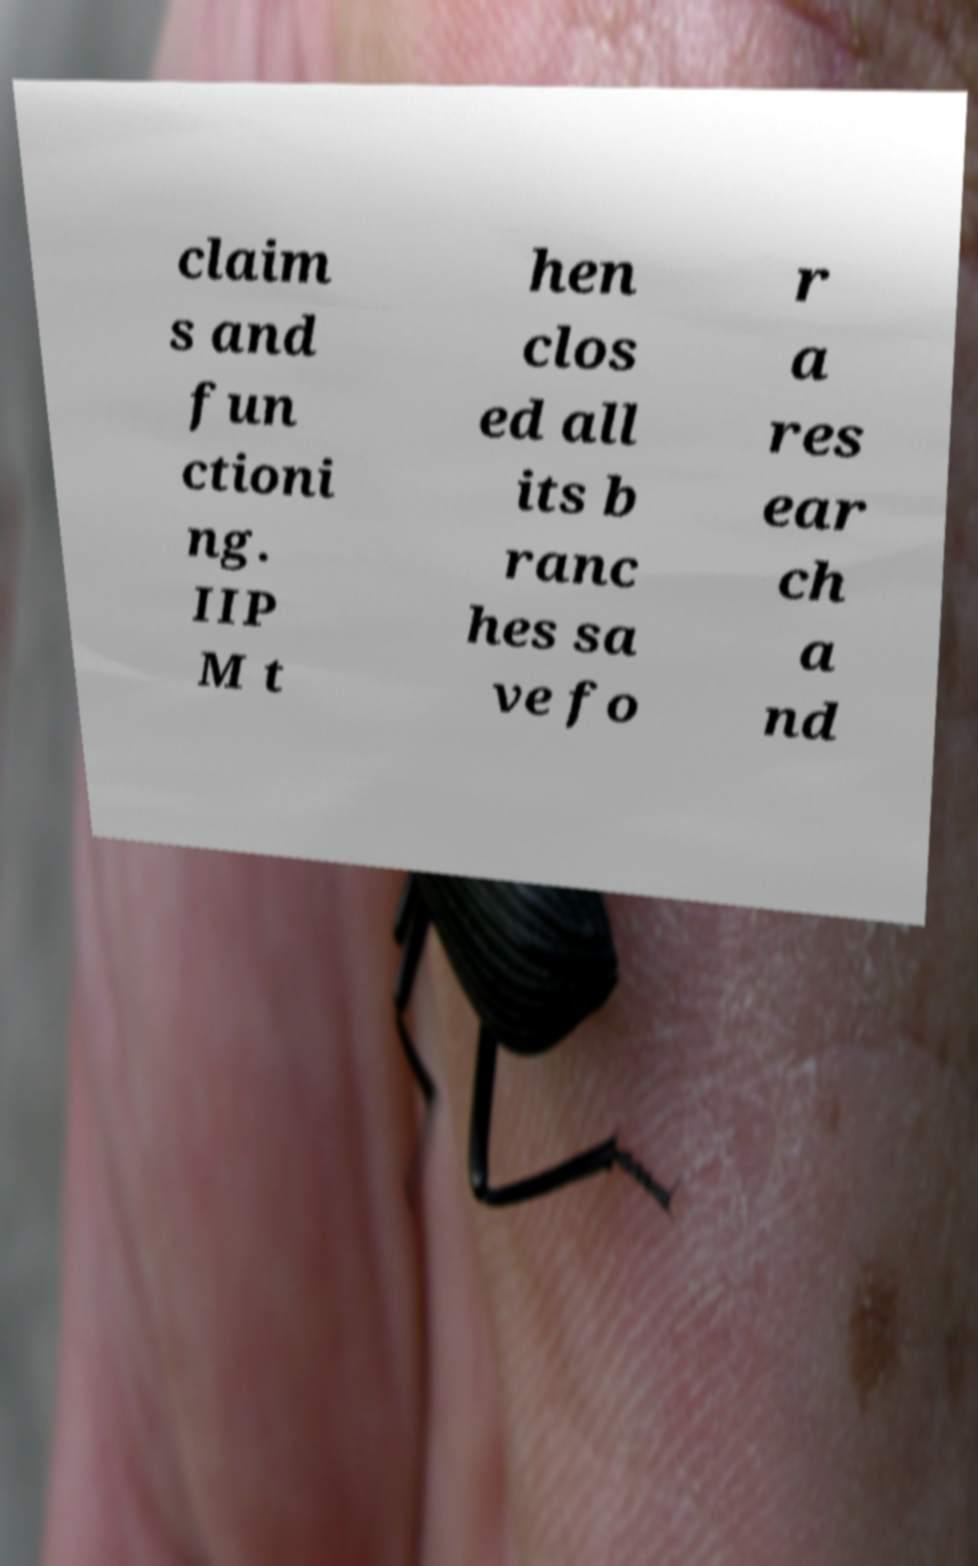There's text embedded in this image that I need extracted. Can you transcribe it verbatim? claim s and fun ctioni ng. IIP M t hen clos ed all its b ranc hes sa ve fo r a res ear ch a nd 